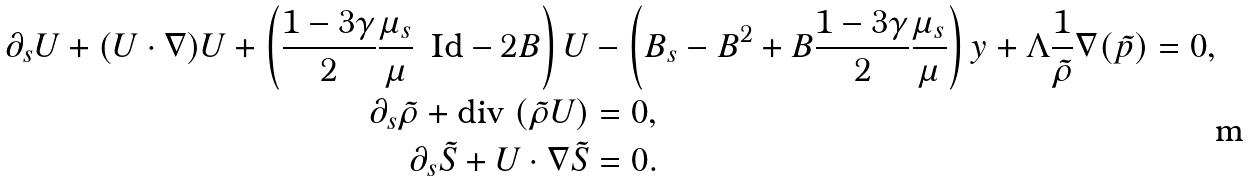<formula> <loc_0><loc_0><loc_500><loc_500>\partial _ { s } { U } + ( { U } \cdot \nabla ) { U } + \left ( \frac { 1 - 3 \gamma } { 2 } \frac { \mu _ { s } } { \mu } \, \text { Id} - 2 B \right ) { U } & - \left ( B _ { s } - B ^ { 2 } + B \frac { 1 - 3 \gamma } { 2 } \frac { \mu _ { s } } { \mu } \right ) y + \Lambda \frac { 1 } { \tilde { \rho } } \nabla ( \tilde { p } ) = 0 , \\ \partial _ { s } \tilde { \rho } + \text {div} \, \left ( \tilde { \rho } { U } \right ) & = 0 , \\ \partial _ { s } \tilde { S } + U \cdot \nabla \tilde { S } & = 0 .</formula> 